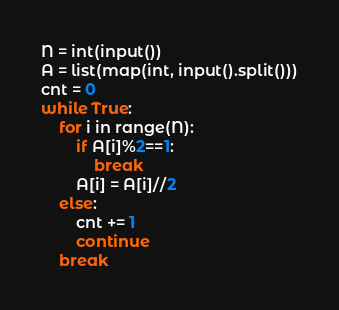<code> <loc_0><loc_0><loc_500><loc_500><_Python_>N = int(input())
A = list(map(int, input().split()))
cnt = 0
while True:
    for i in range(N):
        if A[i]%2==1:
            break
        A[i] = A[i]//2
    else:
        cnt += 1
        continue
    break</code> 